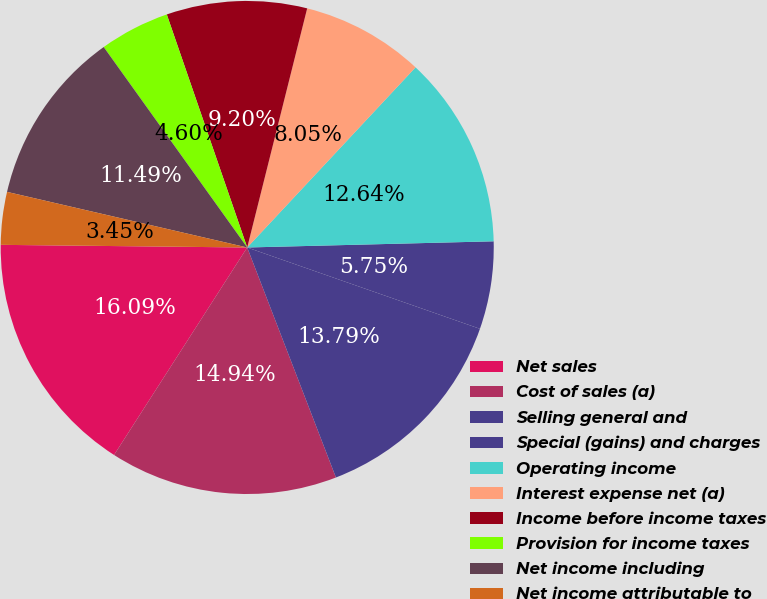Convert chart. <chart><loc_0><loc_0><loc_500><loc_500><pie_chart><fcel>Net sales<fcel>Cost of sales (a)<fcel>Selling general and<fcel>Special (gains) and charges<fcel>Operating income<fcel>Interest expense net (a)<fcel>Income before income taxes<fcel>Provision for income taxes<fcel>Net income including<fcel>Net income attributable to<nl><fcel>16.09%<fcel>14.94%<fcel>13.79%<fcel>5.75%<fcel>12.64%<fcel>8.05%<fcel>9.2%<fcel>4.6%<fcel>11.49%<fcel>3.45%<nl></chart> 